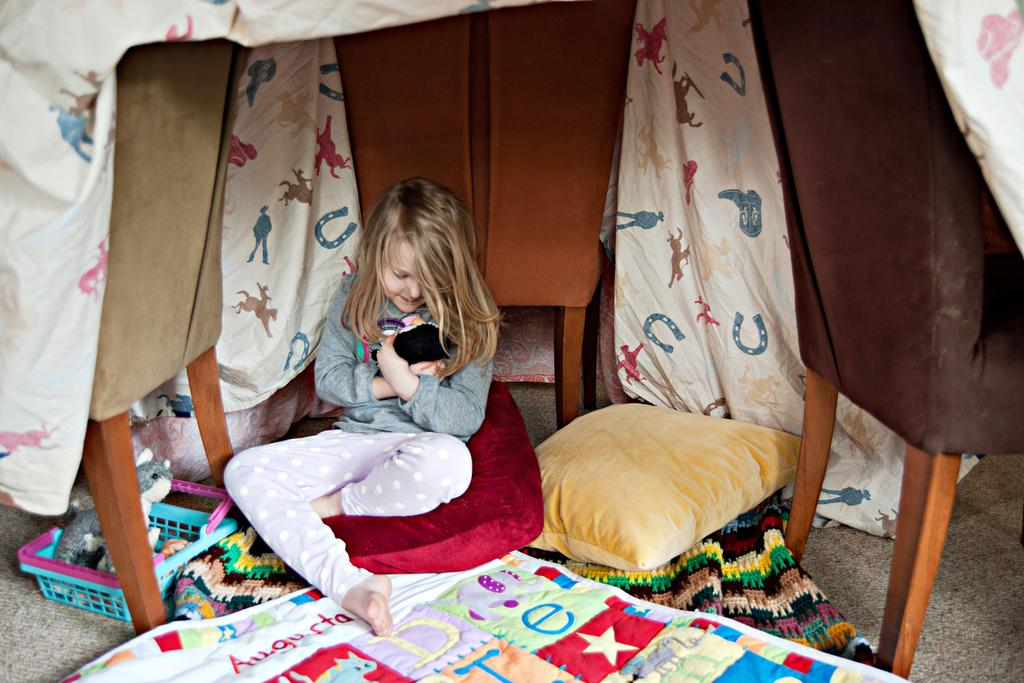Who is in the picture? There is a girl in the picture. What is the girl sitting on? The girl is sitting on a pillow. What is the girl holding in the picture? The girl is holding a toy. What type of flooring is visible in the image? There are carpets in the image. What else can be seen in the image besides the girl? There is a pillow, cloths, chairs, toys, and a tray in the image. What type of board game is the girl playing with the pet in the image? There is no board game or pet present in the image. 